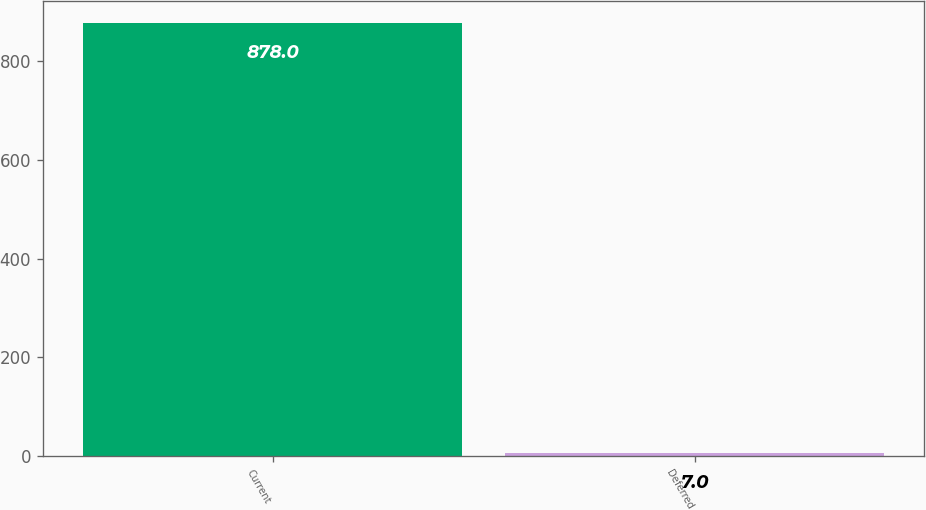Convert chart to OTSL. <chart><loc_0><loc_0><loc_500><loc_500><bar_chart><fcel>Current<fcel>Deferred<nl><fcel>878<fcel>7<nl></chart> 